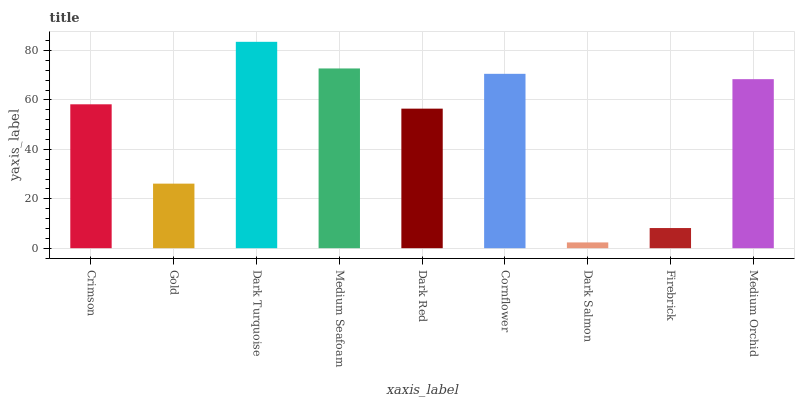Is Gold the minimum?
Answer yes or no. No. Is Gold the maximum?
Answer yes or no. No. Is Crimson greater than Gold?
Answer yes or no. Yes. Is Gold less than Crimson?
Answer yes or no. Yes. Is Gold greater than Crimson?
Answer yes or no. No. Is Crimson less than Gold?
Answer yes or no. No. Is Crimson the high median?
Answer yes or no. Yes. Is Crimson the low median?
Answer yes or no. Yes. Is Cornflower the high median?
Answer yes or no. No. Is Dark Salmon the low median?
Answer yes or no. No. 